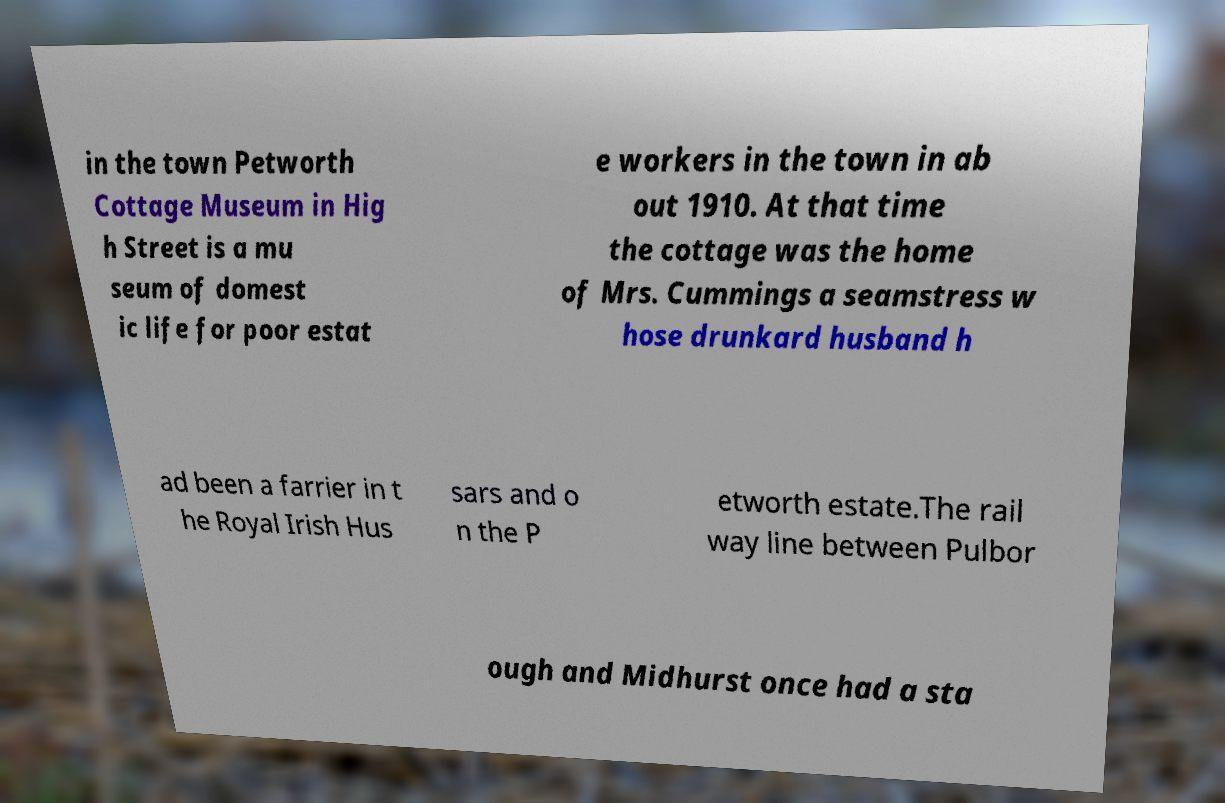Could you assist in decoding the text presented in this image and type it out clearly? in the town Petworth Cottage Museum in Hig h Street is a mu seum of domest ic life for poor estat e workers in the town in ab out 1910. At that time the cottage was the home of Mrs. Cummings a seamstress w hose drunkard husband h ad been a farrier in t he Royal Irish Hus sars and o n the P etworth estate.The rail way line between Pulbor ough and Midhurst once had a sta 